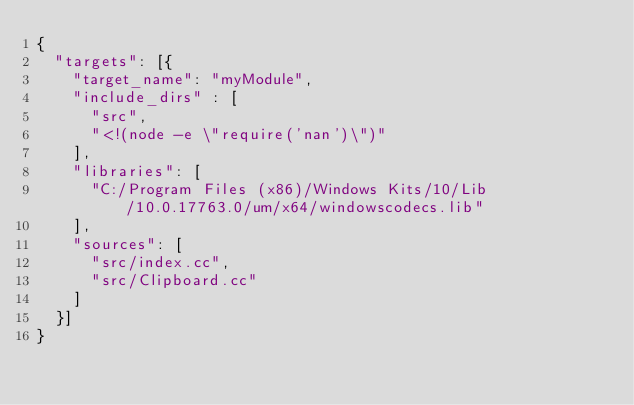<code> <loc_0><loc_0><loc_500><loc_500><_Python_>{
  "targets": [{
    "target_name": "myModule",
    "include_dirs" : [
      "src",
      "<!(node -e \"require('nan')\")"
    ],
    "libraries": [
      "C:/Program Files (x86)/Windows Kits/10/Lib/10.0.17763.0/um/x64/windowscodecs.lib"
    ],
    "sources": [
      "src/index.cc",
      "src/Clipboard.cc"
    ]
  }]
}</code> 